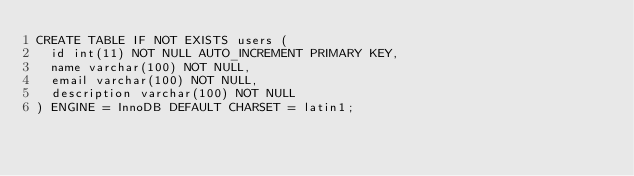<code> <loc_0><loc_0><loc_500><loc_500><_SQL_>CREATE TABLE IF NOT EXISTS users (
  id int(11) NOT NULL AUTO_INCREMENT PRIMARY KEY,
  name varchar(100) NOT NULL,
  email varchar(100) NOT NULL,
  description varchar(100) NOT NULL
) ENGINE = InnoDB DEFAULT CHARSET = latin1;</code> 